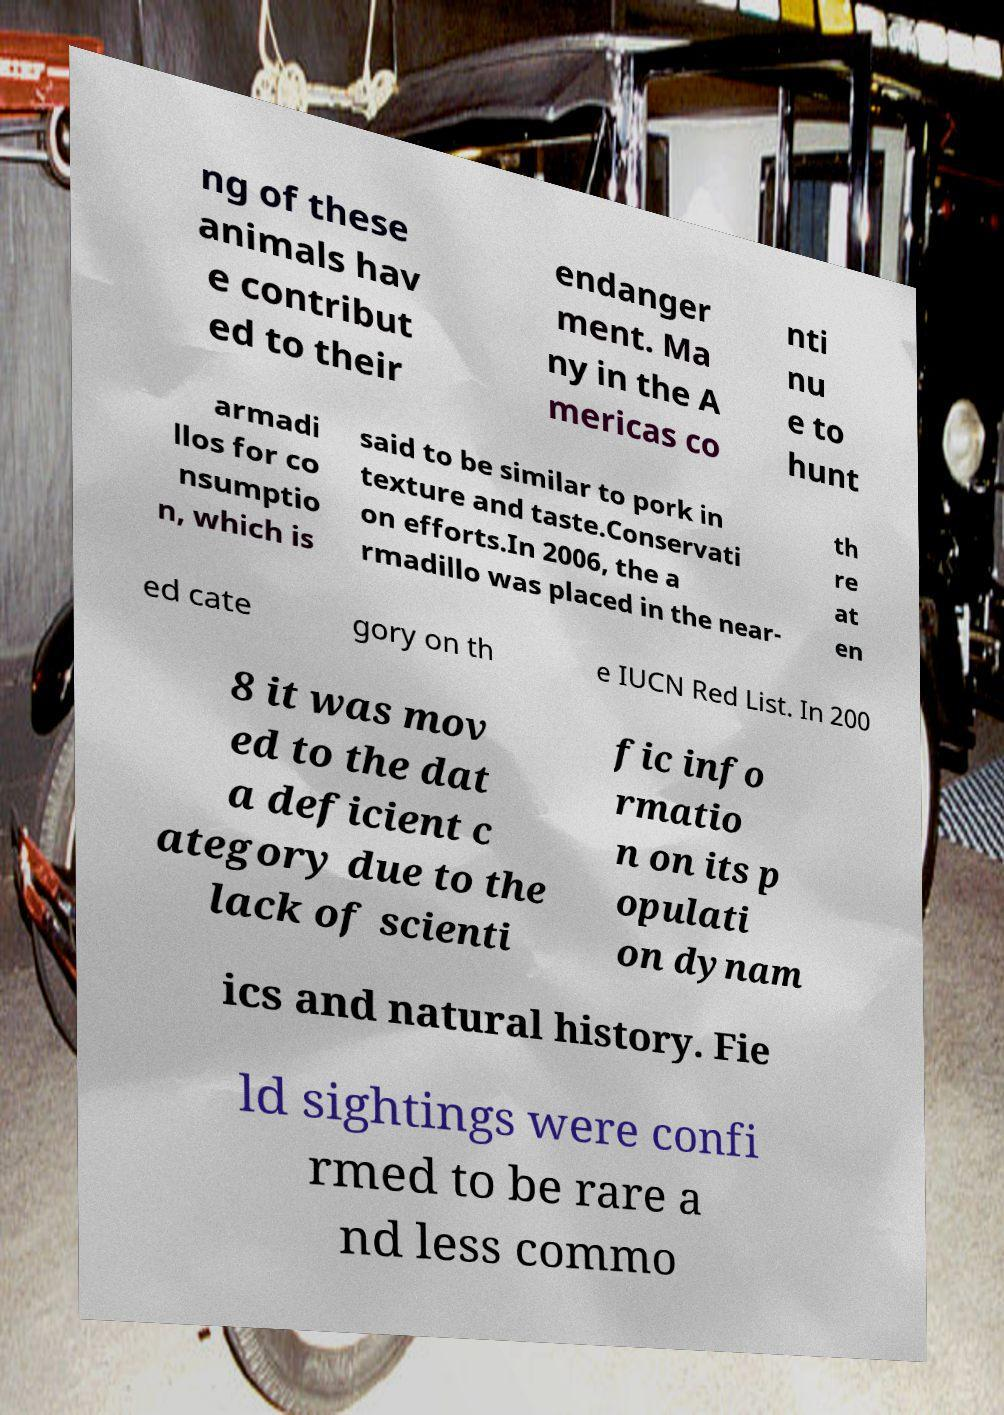Could you extract and type out the text from this image? ng of these animals hav e contribut ed to their endanger ment. Ma ny in the A mericas co nti nu e to hunt armadi llos for co nsumptio n, which is said to be similar to pork in texture and taste.Conservati on efforts.In 2006, the a rmadillo was placed in the near- th re at en ed cate gory on th e IUCN Red List. In 200 8 it was mov ed to the dat a deficient c ategory due to the lack of scienti fic info rmatio n on its p opulati on dynam ics and natural history. Fie ld sightings were confi rmed to be rare a nd less commo 